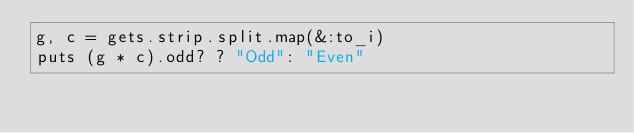Convert code to text. <code><loc_0><loc_0><loc_500><loc_500><_Ruby_>g, c = gets.strip.split.map(&:to_i)
puts (g * c).odd? ? "Odd": "Even"</code> 